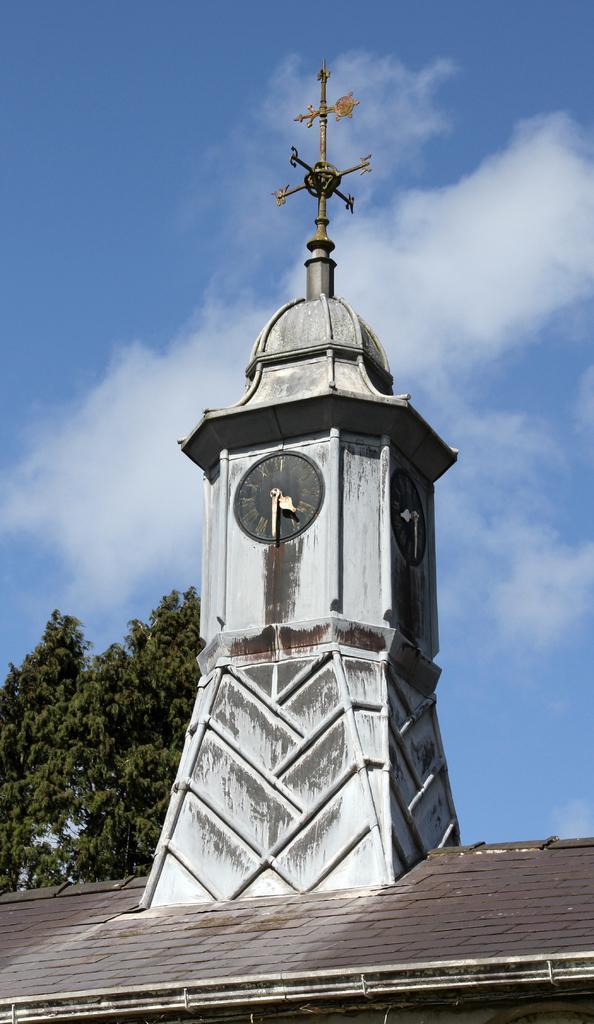In one or two sentences, can you explain what this image depicts? In the picture we can see a roof on it, we can see a clock tower with a clock and top of it, we can see some rod showing some directions east, west, north and south and in the background we can see some trees, and sky with clouds. 